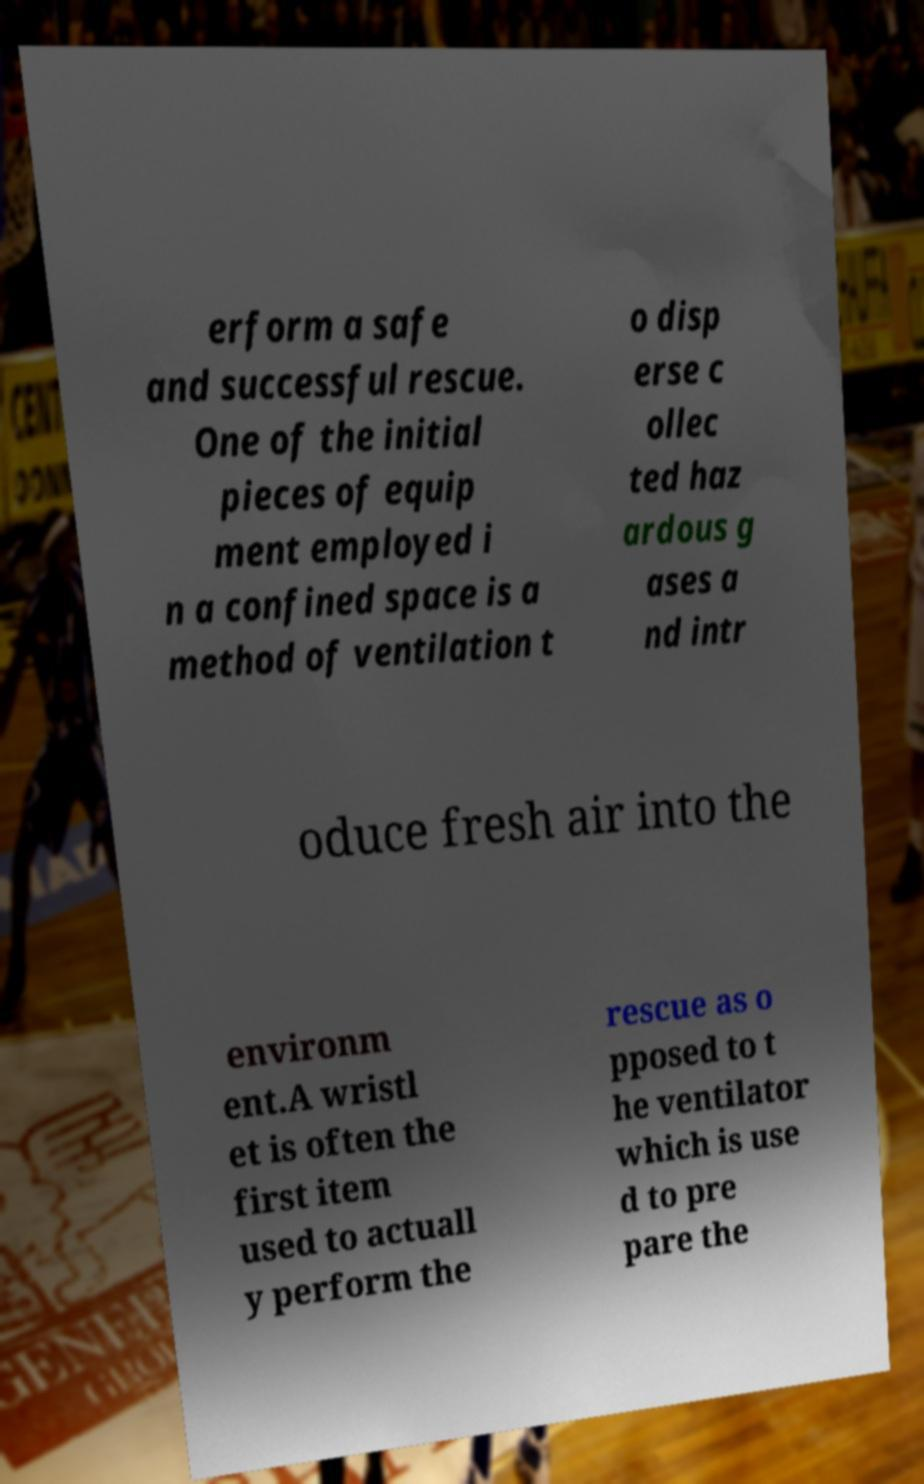Please read and relay the text visible in this image. What does it say? erform a safe and successful rescue. One of the initial pieces of equip ment employed i n a confined space is a method of ventilation t o disp erse c ollec ted haz ardous g ases a nd intr oduce fresh air into the environm ent.A wristl et is often the first item used to actuall y perform the rescue as o pposed to t he ventilator which is use d to pre pare the 